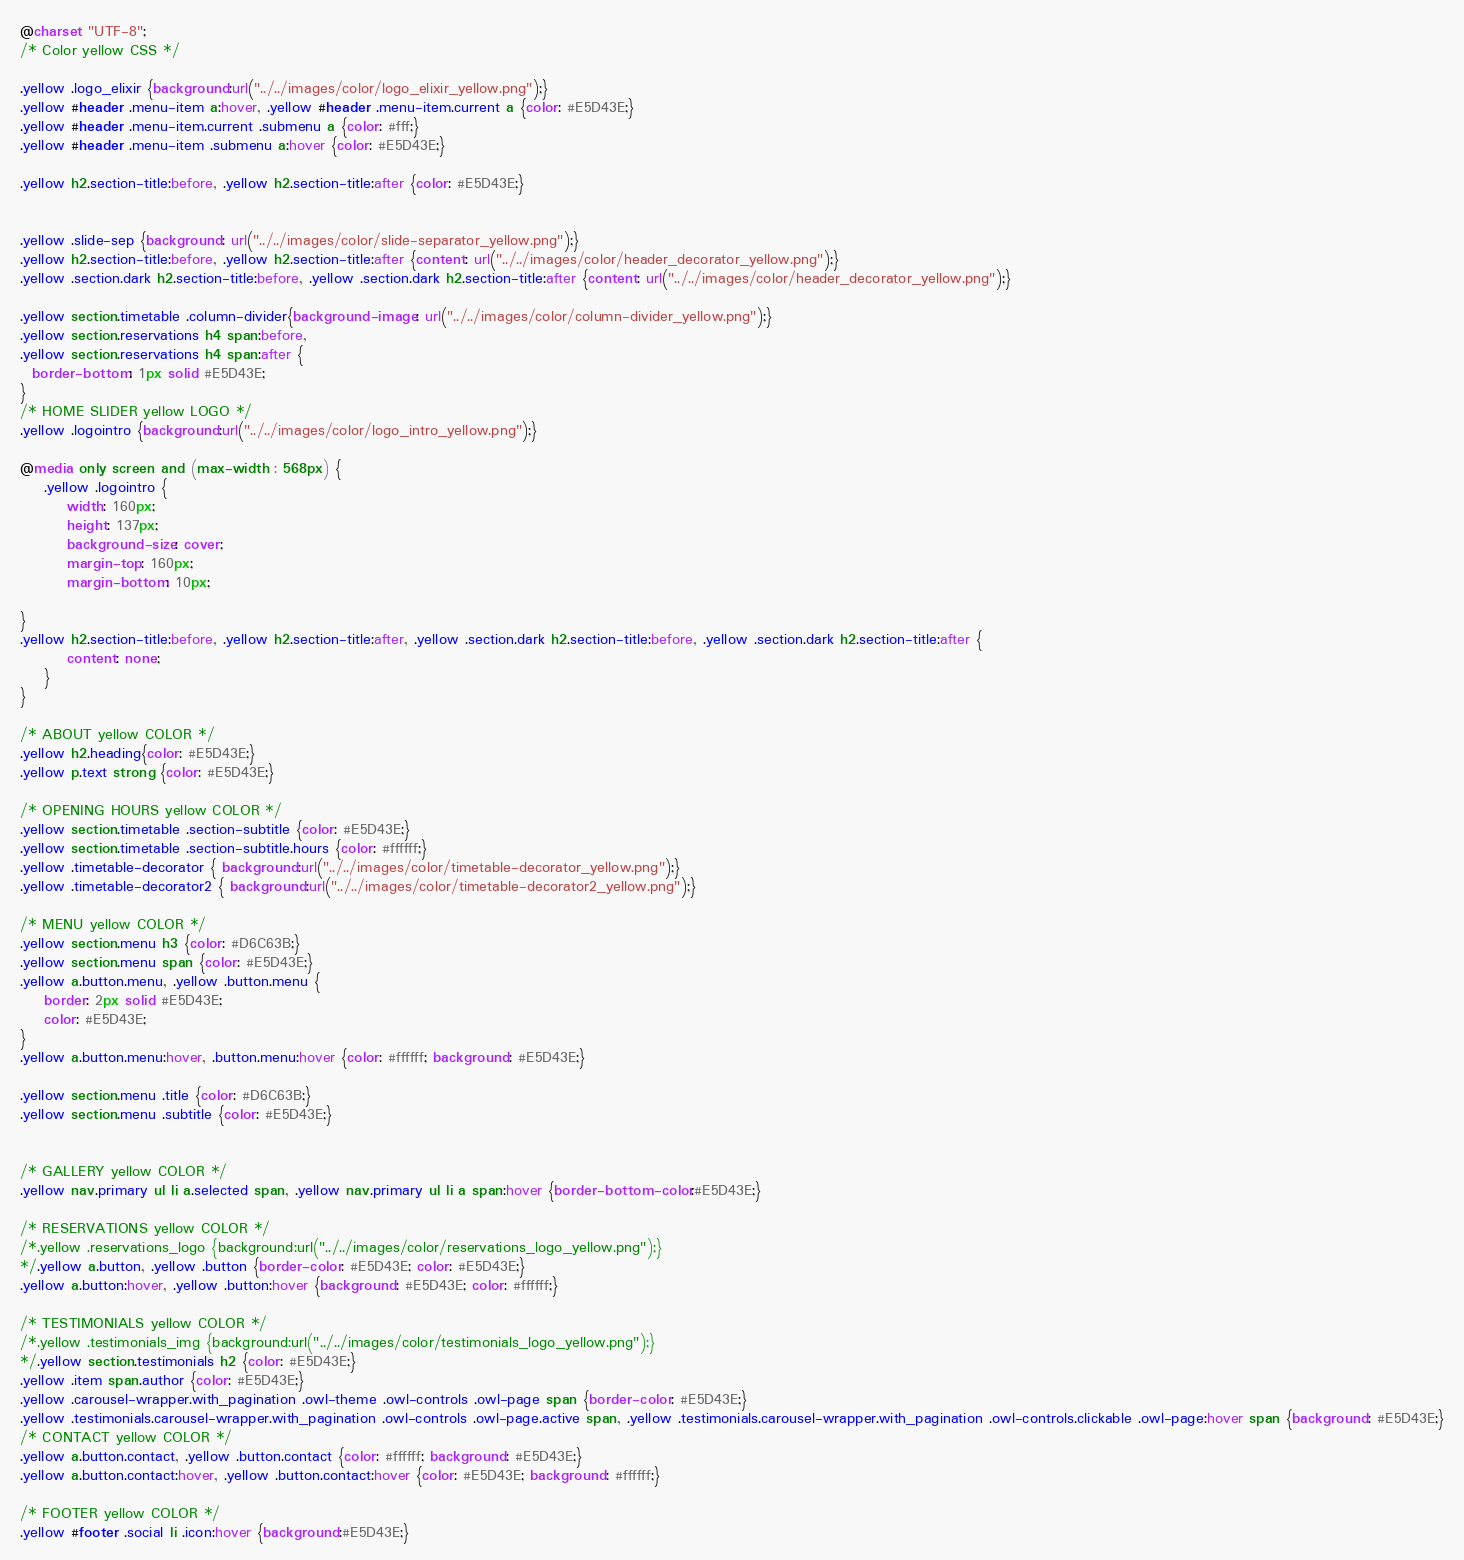<code> <loc_0><loc_0><loc_500><loc_500><_CSS_>@charset "UTF-8";
/* Color yellow CSS */

.yellow .logo_elixir {background:url("../../images/color/logo_elixir_yellow.png");}
.yellow #header .menu-item a:hover, .yellow #header .menu-item.current a {color: #E5D43E;}
.yellow #header .menu-item.current .submenu a {color: #fff;}
.yellow #header .menu-item .submenu a:hover {color: #E5D43E;}

.yellow h2.section-title:before, .yellow h2.section-title:after {color: #E5D43E;}


.yellow .slide-sep {background: url("../../images/color/slide-separator_yellow.png");}
.yellow h2.section-title:before, .yellow h2.section-title:after {content: url("../../images/color/header_decorator_yellow.png");}
.yellow .section.dark h2.section-title:before, .yellow .section.dark h2.section-title:after {content: url("../../images/color/header_decorator_yellow.png");}

.yellow section.timetable .column-divider{background-image: url("../../images/color/column-divider_yellow.png");}
.yellow section.reservations h4 span:before,
.yellow section.reservations h4 span:after {
  border-bottom: 1px solid #E5D43E;
}
/* HOME SLIDER yellow LOGO */
.yellow .logointro {background:url("../../images/color/logo_intro_yellow.png");}

@media only screen and (max-width : 568px) {
	.yellow .logointro {
		width: 160px;
		height: 137px;
		background-size: cover;
		margin-top: 160px;
		margin-bottom: 10px;

}
.yellow h2.section-title:before, .yellow h2.section-title:after, .yellow .section.dark h2.section-title:before, .yellow .section.dark h2.section-title:after {
		content: none;
	}
}

/* ABOUT yellow COLOR */
.yellow h2.heading{color: #E5D43E;}
.yellow p.text strong {color: #E5D43E;}

/* OPENING HOURS yellow COLOR */
.yellow section.timetable .section-subtitle {color: #E5D43E;}
.yellow section.timetable .section-subtitle.hours {color: #ffffff;}
.yellow .timetable-decorator { background:url("../../images/color/timetable-decorator_yellow.png");}
.yellow .timetable-decorator2 { background:url("../../images/color/timetable-decorator2_yellow.png");}

/* MENU yellow COLOR */
.yellow section.menu h3 {color: #D6C63B;}
.yellow section.menu span {color: #E5D43E;}
.yellow a.button.menu, .yellow .button.menu {
	border: 2px solid #E5D43E;
	color: #E5D43E;
}
.yellow a.button.menu:hover, .button.menu:hover {color: #ffffff; background: #E5D43E;}

.yellow section.menu .title {color: #D6C63B;}
.yellow section.menu .subtitle {color: #E5D43E;}


/* GALLERY yellow COLOR */
.yellow nav.primary ul li a.selected span, .yellow nav.primary ul li a span:hover {border-bottom-color:#E5D43E;}

/* RESERVATIONS yellow COLOR */
/*.yellow .reservations_logo {background:url("../../images/color/reservations_logo_yellow.png");}
*/.yellow a.button, .yellow .button {border-color: #E5D43E; color: #E5D43E;}
.yellow a.button:hover, .yellow .button:hover {background: #E5D43E; color: #ffffff;}

/* TESTIMONIALS yellow COLOR */
/*.yellow .testimonials_img {background:url("../../images/color/testimonials_logo_yellow.png");}
*/.yellow section.testimonials h2 {color: #E5D43E;}
.yellow .item span.author {color: #E5D43E;}
.yellow .carousel-wrapper.with_pagination .owl-theme .owl-controls .owl-page span {border-color: #E5D43E;}
.yellow .testimonials.carousel-wrapper.with_pagination .owl-controls .owl-page.active span, .yellow .testimonials.carousel-wrapper.with_pagination .owl-controls.clickable .owl-page:hover span {background: #E5D43E;}
/* CONTACT yellow COLOR */
.yellow a.button.contact, .yellow .button.contact {color: #ffffff; background: #E5D43E;}
.yellow a.button.contact:hover, .yellow .button.contact:hover {color: #E5D43E; background: #ffffff;}

/* FOOTER yellow COLOR */
.yellow #footer .social li .icon:hover {background:#E5D43E;}
</code> 